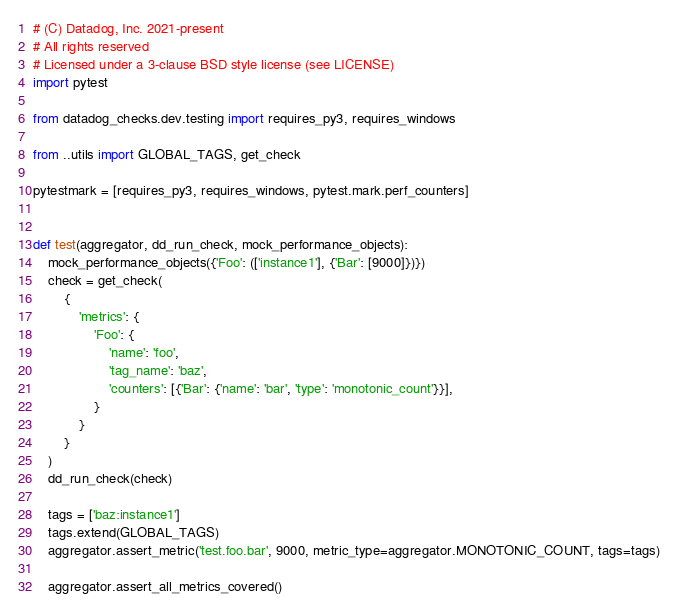<code> <loc_0><loc_0><loc_500><loc_500><_Python_># (C) Datadog, Inc. 2021-present
# All rights reserved
# Licensed under a 3-clause BSD style license (see LICENSE)
import pytest

from datadog_checks.dev.testing import requires_py3, requires_windows

from ..utils import GLOBAL_TAGS, get_check

pytestmark = [requires_py3, requires_windows, pytest.mark.perf_counters]


def test(aggregator, dd_run_check, mock_performance_objects):
    mock_performance_objects({'Foo': (['instance1'], {'Bar': [9000]})})
    check = get_check(
        {
            'metrics': {
                'Foo': {
                    'name': 'foo',
                    'tag_name': 'baz',
                    'counters': [{'Bar': {'name': 'bar', 'type': 'monotonic_count'}}],
                }
            }
        }
    )
    dd_run_check(check)

    tags = ['baz:instance1']
    tags.extend(GLOBAL_TAGS)
    aggregator.assert_metric('test.foo.bar', 9000, metric_type=aggregator.MONOTONIC_COUNT, tags=tags)

    aggregator.assert_all_metrics_covered()
</code> 